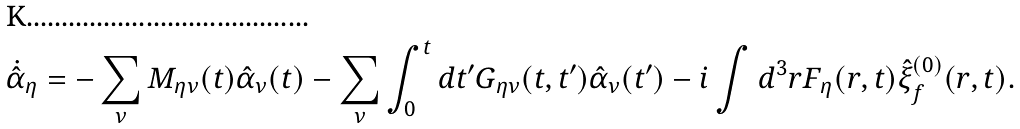<formula> <loc_0><loc_0><loc_500><loc_500>\dot { \hat { \alpha } } _ { \eta } = - \sum _ { \nu } M _ { \eta \nu } ( t ) \hat { \alpha } _ { \nu } ( t ) - \sum _ { \nu } \int _ { 0 } ^ { t } d t ^ { \prime } G _ { \eta \nu } ( t , t ^ { \prime } ) \hat { \alpha } _ { \nu } ( t ^ { \prime } ) - i \int d ^ { 3 } { r } F _ { \eta } ( { r } , t ) \hat { \xi } ^ { ( 0 ) } _ { f } ( { r } , t ) .</formula> 